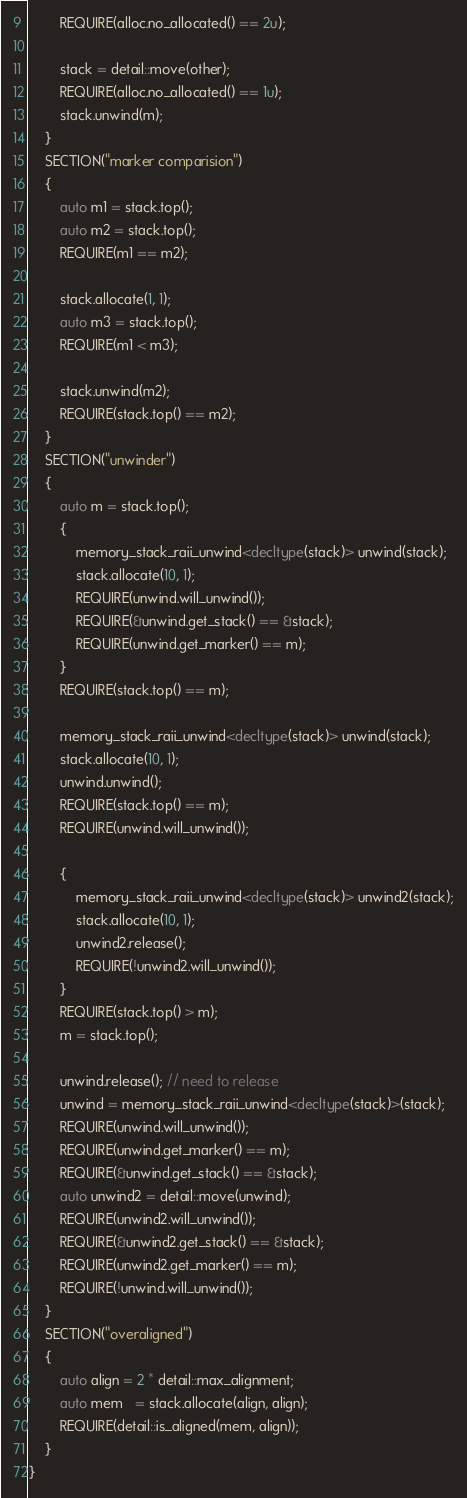Convert code to text. <code><loc_0><loc_0><loc_500><loc_500><_C++_>        REQUIRE(alloc.no_allocated() == 2u);

        stack = detail::move(other);
        REQUIRE(alloc.no_allocated() == 1u);
        stack.unwind(m);
    }
    SECTION("marker comparision")
    {
        auto m1 = stack.top();
        auto m2 = stack.top();
        REQUIRE(m1 == m2);

        stack.allocate(1, 1);
        auto m3 = stack.top();
        REQUIRE(m1 < m3);

        stack.unwind(m2);
        REQUIRE(stack.top() == m2);
    }
    SECTION("unwinder")
    {
        auto m = stack.top();
        {
            memory_stack_raii_unwind<decltype(stack)> unwind(stack);
            stack.allocate(10, 1);
            REQUIRE(unwind.will_unwind());
            REQUIRE(&unwind.get_stack() == &stack);
            REQUIRE(unwind.get_marker() == m);
        }
        REQUIRE(stack.top() == m);

        memory_stack_raii_unwind<decltype(stack)> unwind(stack);
        stack.allocate(10, 1);
        unwind.unwind();
        REQUIRE(stack.top() == m);
        REQUIRE(unwind.will_unwind());

        {
            memory_stack_raii_unwind<decltype(stack)> unwind2(stack);
            stack.allocate(10, 1);
            unwind2.release();
            REQUIRE(!unwind2.will_unwind());
        }
        REQUIRE(stack.top() > m);
        m = stack.top();

        unwind.release(); // need to release
        unwind = memory_stack_raii_unwind<decltype(stack)>(stack);
        REQUIRE(unwind.will_unwind());
        REQUIRE(unwind.get_marker() == m);
        REQUIRE(&unwind.get_stack() == &stack);
        auto unwind2 = detail::move(unwind);
        REQUIRE(unwind2.will_unwind());
        REQUIRE(&unwind2.get_stack() == &stack);
        REQUIRE(unwind2.get_marker() == m);
        REQUIRE(!unwind.will_unwind());
    }
    SECTION("overaligned")
    {
        auto align = 2 * detail::max_alignment;
        auto mem   = stack.allocate(align, align);
        REQUIRE(detail::is_aligned(mem, align));
    }
}
</code> 